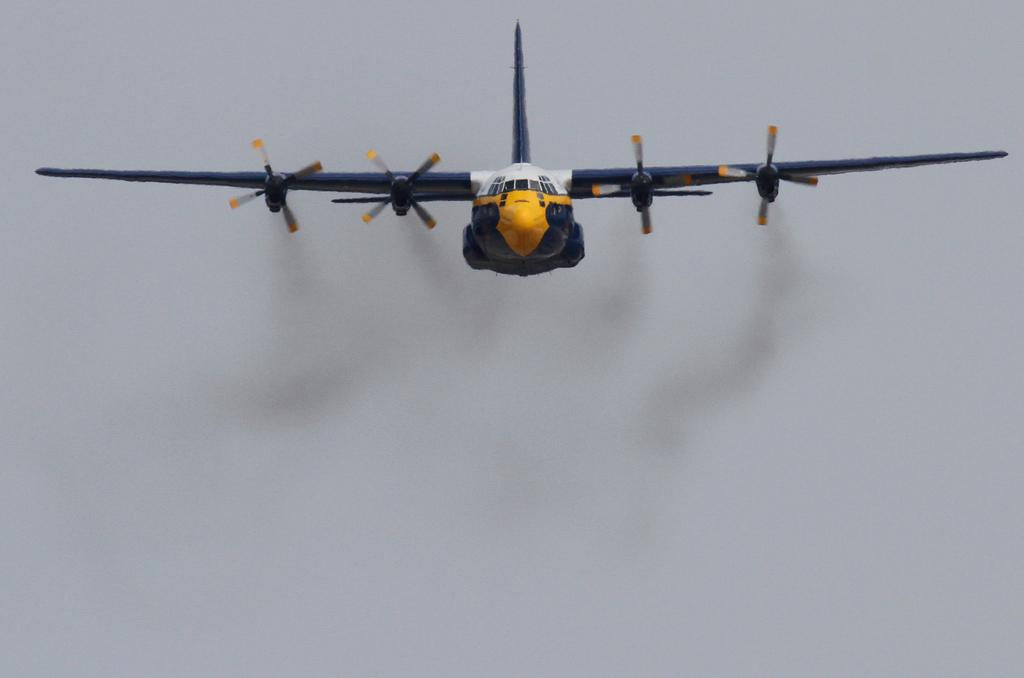What is the main subject of the image? The main subject of the image is an aircraft. Can you describe the position of the aircraft in the image? The aircraft is in the air. What can be seen under the aircraft in the image? There is black smoke visible under the aircraft. What type of mitten is being used by the aircraft in the image? There is no mitten present in the image, as the subject is an aircraft and not a person wearing mittens. 